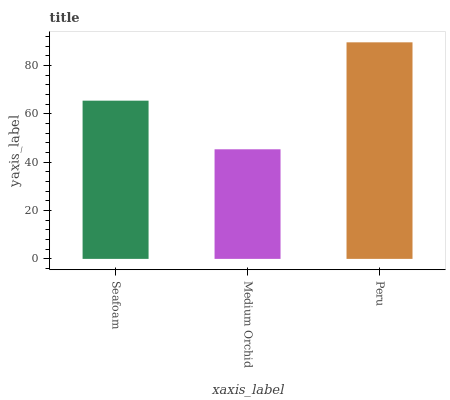Is Medium Orchid the minimum?
Answer yes or no. Yes. Is Peru the maximum?
Answer yes or no. Yes. Is Peru the minimum?
Answer yes or no. No. Is Medium Orchid the maximum?
Answer yes or no. No. Is Peru greater than Medium Orchid?
Answer yes or no. Yes. Is Medium Orchid less than Peru?
Answer yes or no. Yes. Is Medium Orchid greater than Peru?
Answer yes or no. No. Is Peru less than Medium Orchid?
Answer yes or no. No. Is Seafoam the high median?
Answer yes or no. Yes. Is Seafoam the low median?
Answer yes or no. Yes. Is Peru the high median?
Answer yes or no. No. Is Medium Orchid the low median?
Answer yes or no. No. 